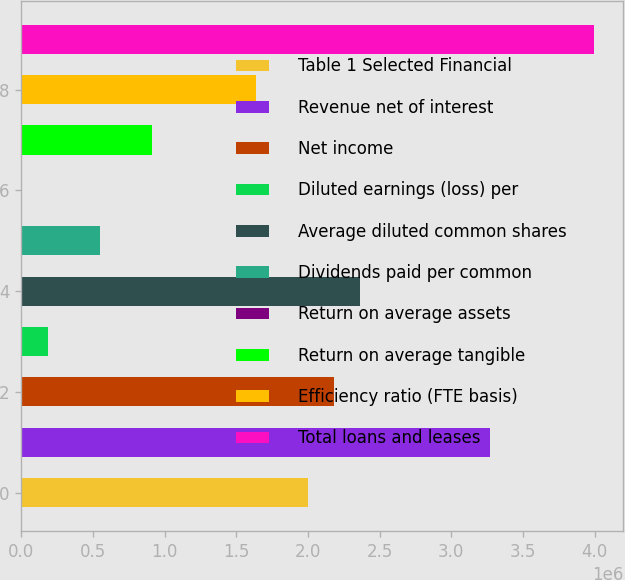<chart> <loc_0><loc_0><loc_500><loc_500><bar_chart><fcel>Table 1 Selected Financial<fcel>Revenue net of interest<fcel>Net income<fcel>Diluted earnings (loss) per<fcel>Average diluted common shares<fcel>Dividends paid per common<fcel>Return on average assets<fcel>Return on average tangible<fcel>Efficiency ratio (FTE basis)<fcel>Total loans and leases<nl><fcel>1.99974e+06<fcel>3.2723e+06<fcel>2.18153e+06<fcel>181794<fcel>2.36333e+06<fcel>545383<fcel>0.22<fcel>908972<fcel>1.63615e+06<fcel>3.99947e+06<nl></chart> 